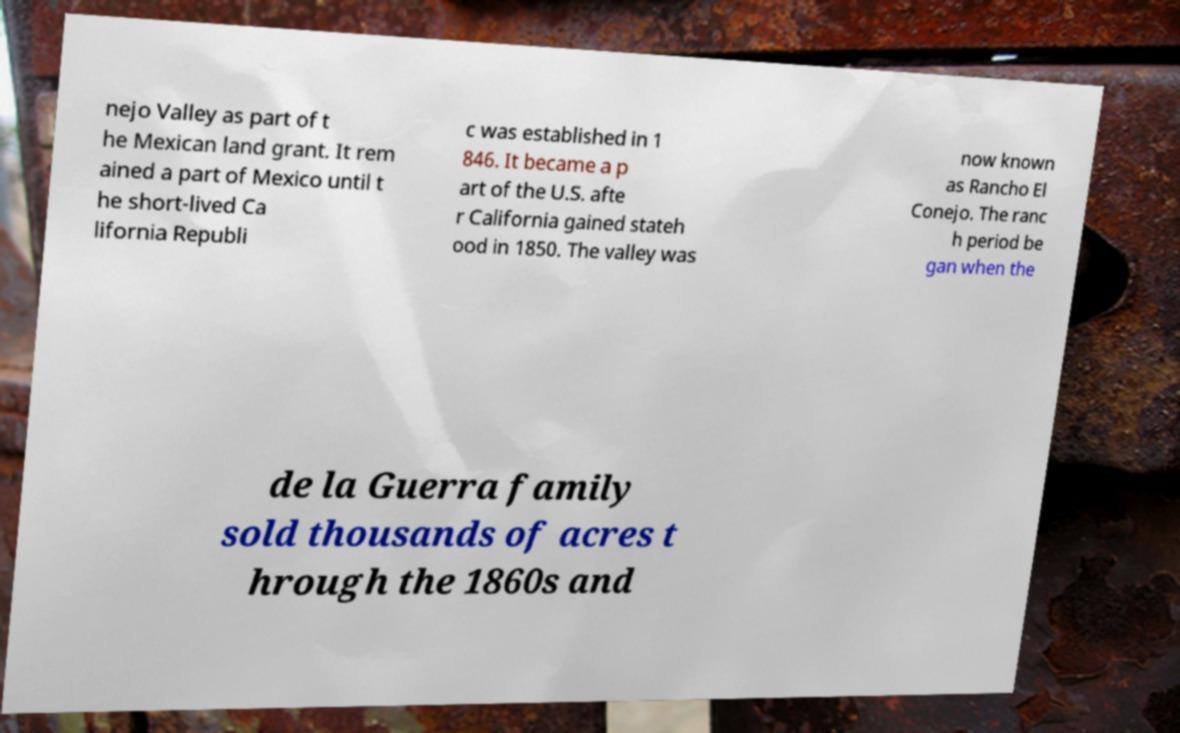I need the written content from this picture converted into text. Can you do that? nejo Valley as part of t he Mexican land grant. It rem ained a part of Mexico until t he short-lived Ca lifornia Republi c was established in 1 846. It became a p art of the U.S. afte r California gained stateh ood in 1850. The valley was now known as Rancho El Conejo. The ranc h period be gan when the de la Guerra family sold thousands of acres t hrough the 1860s and 